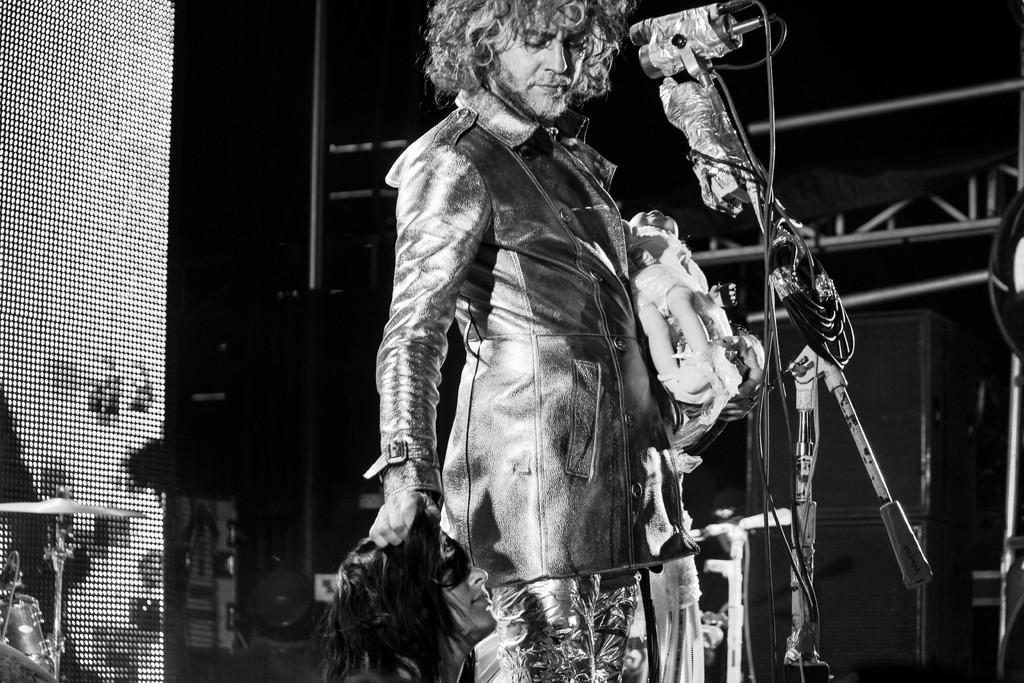Describe this image in one or two sentences. In this picture I can see a man is standing in front of microphones. This picture is black and white in color. On the left side I can see some musical instruments. 